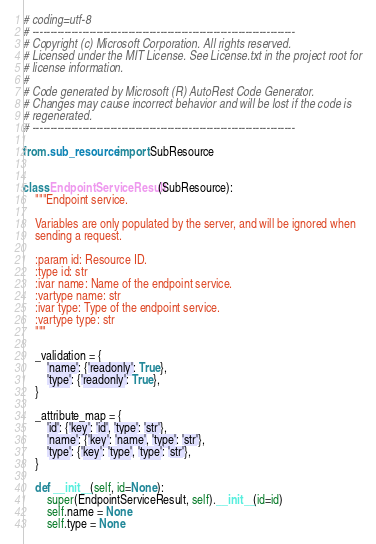<code> <loc_0><loc_0><loc_500><loc_500><_Python_># coding=utf-8
# --------------------------------------------------------------------------
# Copyright (c) Microsoft Corporation. All rights reserved.
# Licensed under the MIT License. See License.txt in the project root for
# license information.
#
# Code generated by Microsoft (R) AutoRest Code Generator.
# Changes may cause incorrect behavior and will be lost if the code is
# regenerated.
# --------------------------------------------------------------------------

from .sub_resource import SubResource


class EndpointServiceResult(SubResource):
    """Endpoint service.

    Variables are only populated by the server, and will be ignored when
    sending a request.

    :param id: Resource ID.
    :type id: str
    :ivar name: Name of the endpoint service.
    :vartype name: str
    :ivar type: Type of the endpoint service.
    :vartype type: str
    """

    _validation = {
        'name': {'readonly': True},
        'type': {'readonly': True},
    }

    _attribute_map = {
        'id': {'key': 'id', 'type': 'str'},
        'name': {'key': 'name', 'type': 'str'},
        'type': {'key': 'type', 'type': 'str'},
    }

    def __init__(self, id=None):
        super(EndpointServiceResult, self).__init__(id=id)
        self.name = None
        self.type = None
</code> 